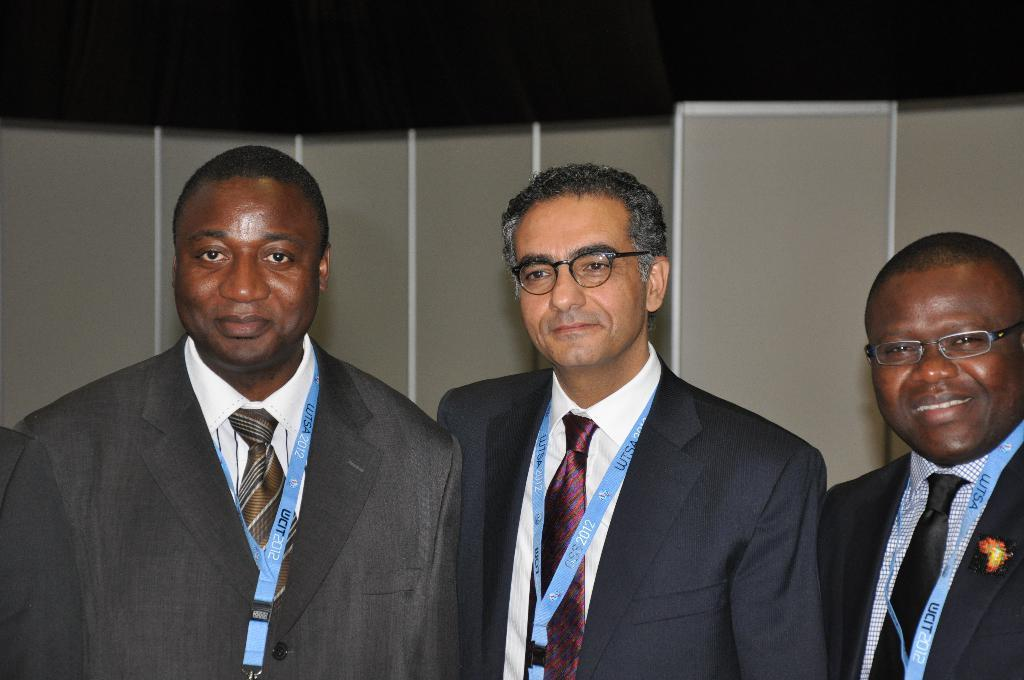Who is present in the image? There are men in the image. What are the men doing in the image? The men are standing. What are the men wearing in the image? The men are wearing suits. What objects do the men have in the image? The men have ID cards. What type of marble is visible on the floor in the image? There is no marble visible on the floor in the image. What kind of lettuce can be seen in the men's hands in the image? There are no men holding lettuce in the image. 